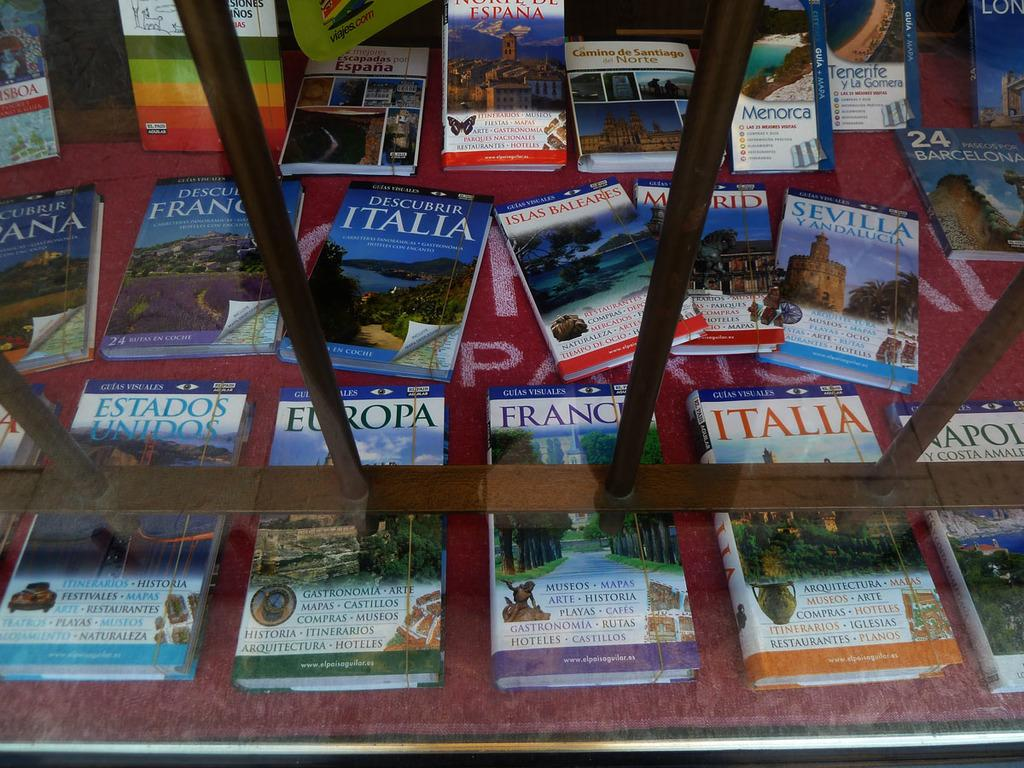<image>
Offer a succinct explanation of the picture presented. A display table with European travel books on it. 